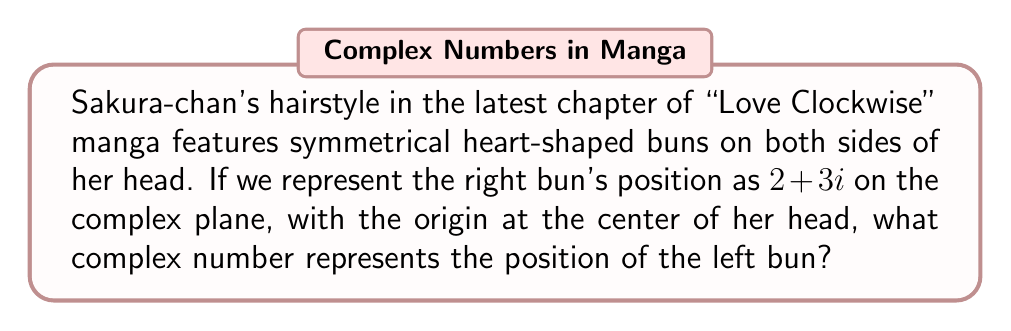What is the answer to this math problem? Let's approach this step-by-step:

1) In the complex plane, the real axis represents horizontal position, and the imaginary axis represents vertical position.

2) The right bun is at $2+3i$, meaning 2 units to the right and 3 units up from the center of Sakura-chan's head.

3) For symmetry, the left bun should be the same distance from the center, but on the opposite side horizontally.

4) To achieve this symmetry, we need to reflect the point $2+3i$ across the imaginary axis.

5) Reflection across the imaginary axis is achieved by negating the real part of a complex number while keeping the imaginary part the same.

6) Therefore, we change $2+3i$ to $-2+3i$.

This gives us the position of the left bun, which is symmetrical to the right bun with respect to the center of Sakura-chan's head.
Answer: $-2+3i$ 